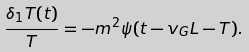<formula> <loc_0><loc_0><loc_500><loc_500>\frac { \delta _ { 1 } T ( t ) } { T } = - m ^ { 2 } \psi ( t - v _ { G } L - T ) .</formula> 